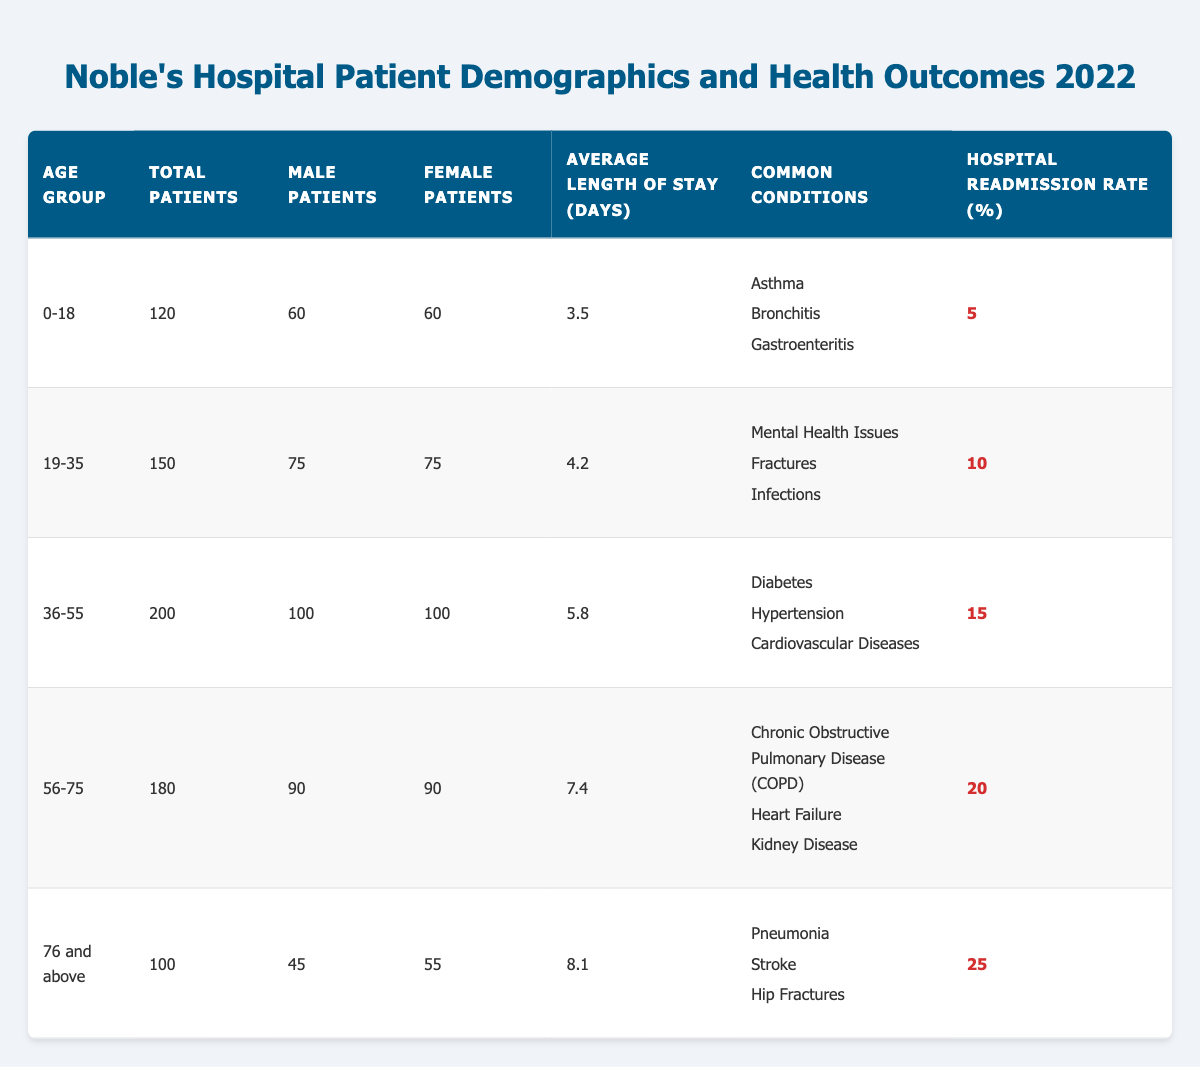What is the total number of patients in the age group 36-55? The total number of patients in the age group 36-55 is specified in the table under "Total Patients." It shows 200 patients in this group.
Answer: 200 What is the hospital readmission rate for patients aged 76 and above? The hospital readmission rate for the age group 76 and above is mentioned directly in the table, which indicates a rate of 25%.
Answer: 25 Which age group has the highest average length of stay in days? By examining the "Average Length of Stay (Days)" column, the age group 76 and above has the highest average length of stay at 8.1 days, compared to others.
Answer: 76 and above Does the age group 19-35 show a lower hospital readmission rate compared to the age group 56-75? The readmission rate for age group 19-35 is 10%, while for age group 56-75 it is 20%. Since 10% is lower than 20%, the statement is true.
Answer: Yes What are the common conditions for patients aged 36-55? The common conditions for this age group are listed in the table under "Common Conditions" and include Diabetes, Hypertension, and Cardiovascular Diseases.
Answer: Diabetes, Hypertension, Cardiovascular Diseases What is the combined total number of female patients in the age groups 0-18 and 56-75? In the age group 0-18, there are 60 female patients, and in the age group 56-75, there are also 90 female patients. Adding these together gives 60 + 90 = 150 female patients in total.
Answer: 150 Which age group has the second highest number of total patients? By comparing the total number of patients across all age groups, the age group 36-55 has 200 patients, which is the second highest after 56-75 (180 patients).
Answer: 36-55 Is it true that more than half of the total patients in the 76 and above age group are female? In the 76 and above age group, there are 55 female patients out of 100 total patients. Since 55 is greater than half of 100, this statement is true.
Answer: Yes What is the difference in hospital readmission rates between the age groups 0-18 and 36-55? The readmission rate for age group 0-18 is 5%, and for age group 36-55, it is 15%. The difference can be calculated as 15 - 5 = 10%.
Answer: 10% 